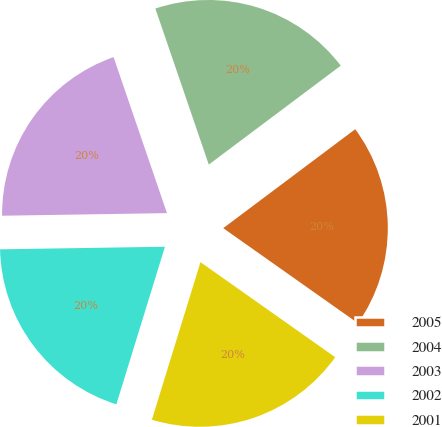<chart> <loc_0><loc_0><loc_500><loc_500><pie_chart><fcel>2005<fcel>2004<fcel>2003<fcel>2002<fcel>2001<nl><fcel>20.02%<fcel>20.01%<fcel>20.0%<fcel>19.99%<fcel>19.98%<nl></chart> 